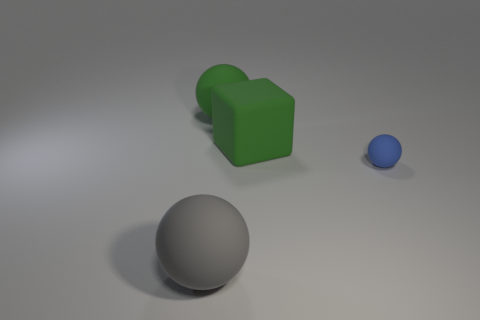What number of rubber spheres have the same color as the matte cube?
Provide a succinct answer. 1. Do the big matte sphere that is behind the small ball and the big matte ball that is in front of the blue matte sphere have the same color?
Your answer should be compact. No. Are there any matte objects to the left of the tiny object?
Offer a terse response. Yes. What is the big green sphere made of?
Ensure brevity in your answer.  Rubber. What is the shape of the gray rubber thing in front of the small blue matte ball?
Ensure brevity in your answer.  Sphere. The ball that is the same color as the big block is what size?
Keep it short and to the point. Large. Is there a gray sphere of the same size as the cube?
Your answer should be compact. Yes. Is the large sphere that is behind the gray matte sphere made of the same material as the green block?
Keep it short and to the point. Yes. Is the number of blue balls behind the big block the same as the number of green matte objects in front of the big green sphere?
Your response must be concise. No. There is a rubber object that is both in front of the rubber block and left of the tiny blue rubber thing; what is its shape?
Offer a terse response. Sphere. 